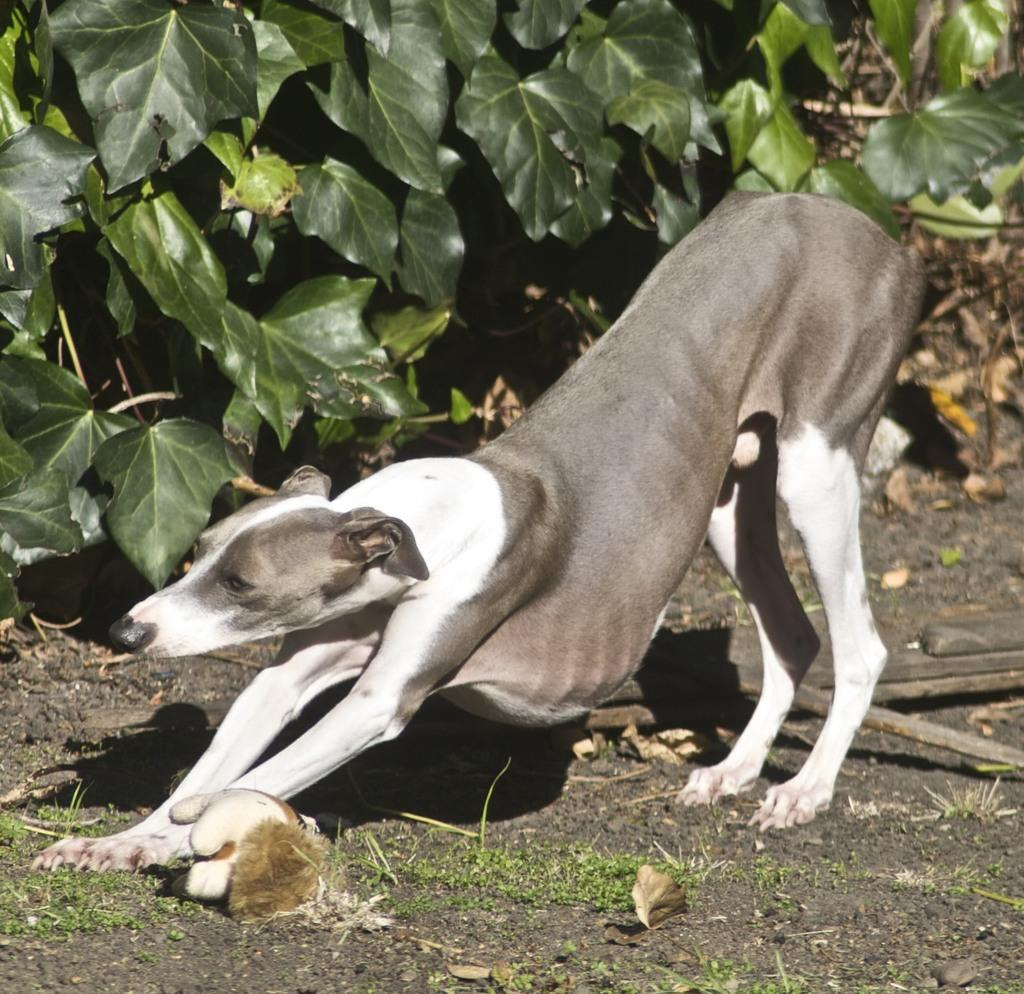What type of animal is present in the image? There is a dog in the image. What other elements can be seen in the image besides the dog? There are plants in the image. What type of veil is draped over the dog in the image? There is no veil present in the image; the dog is not wearing or covered by any veil. 